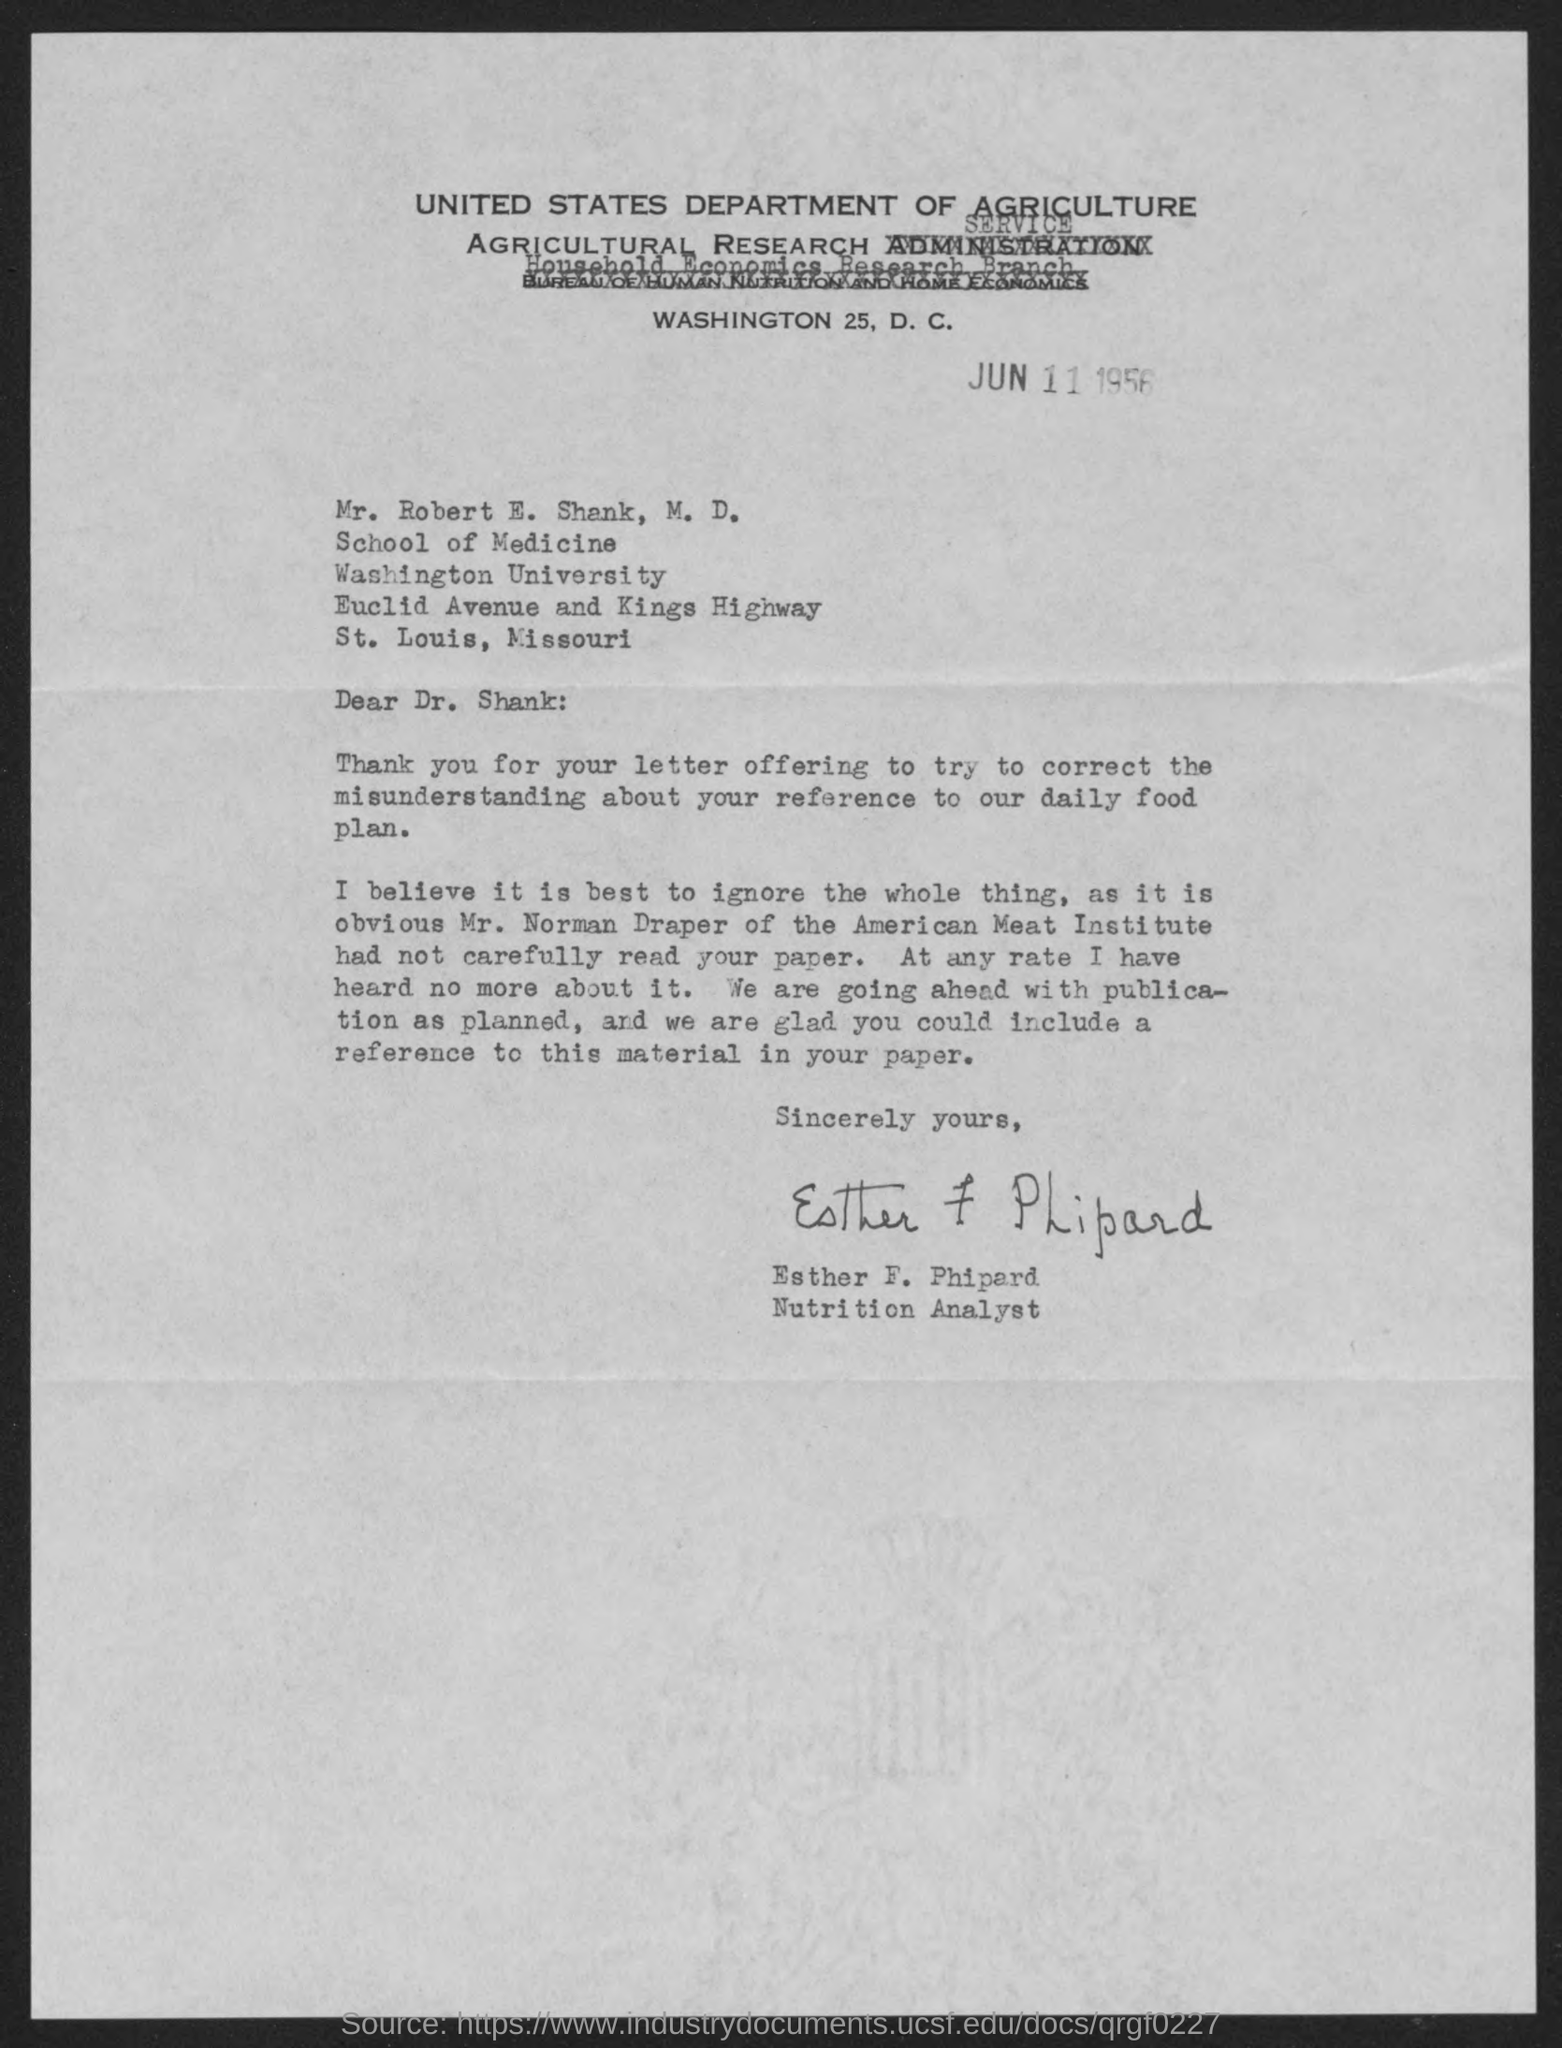Indicate a few pertinent items in this graphic. Esther is a nutrition analyst. The letter has been signed by Esther F. Phipard. The document is dated June 11, 1956. 